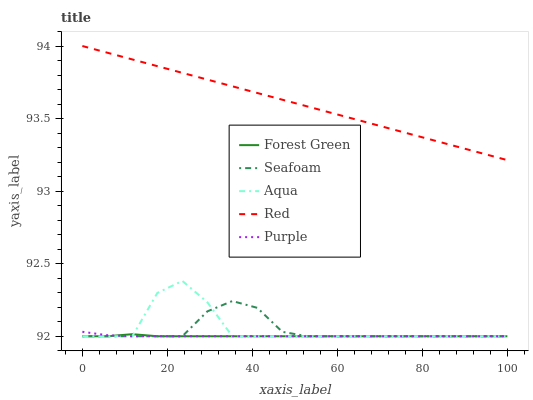Does Forest Green have the minimum area under the curve?
Answer yes or no. Yes. Does Red have the maximum area under the curve?
Answer yes or no. Yes. Does Aqua have the minimum area under the curve?
Answer yes or no. No. Does Aqua have the maximum area under the curve?
Answer yes or no. No. Is Red the smoothest?
Answer yes or no. Yes. Is Aqua the roughest?
Answer yes or no. Yes. Is Forest Green the smoothest?
Answer yes or no. No. Is Forest Green the roughest?
Answer yes or no. No. Does Purple have the lowest value?
Answer yes or no. Yes. Does Red have the lowest value?
Answer yes or no. No. Does Red have the highest value?
Answer yes or no. Yes. Does Aqua have the highest value?
Answer yes or no. No. Is Forest Green less than Red?
Answer yes or no. Yes. Is Red greater than Aqua?
Answer yes or no. Yes. Does Forest Green intersect Aqua?
Answer yes or no. Yes. Is Forest Green less than Aqua?
Answer yes or no. No. Is Forest Green greater than Aqua?
Answer yes or no. No. Does Forest Green intersect Red?
Answer yes or no. No. 